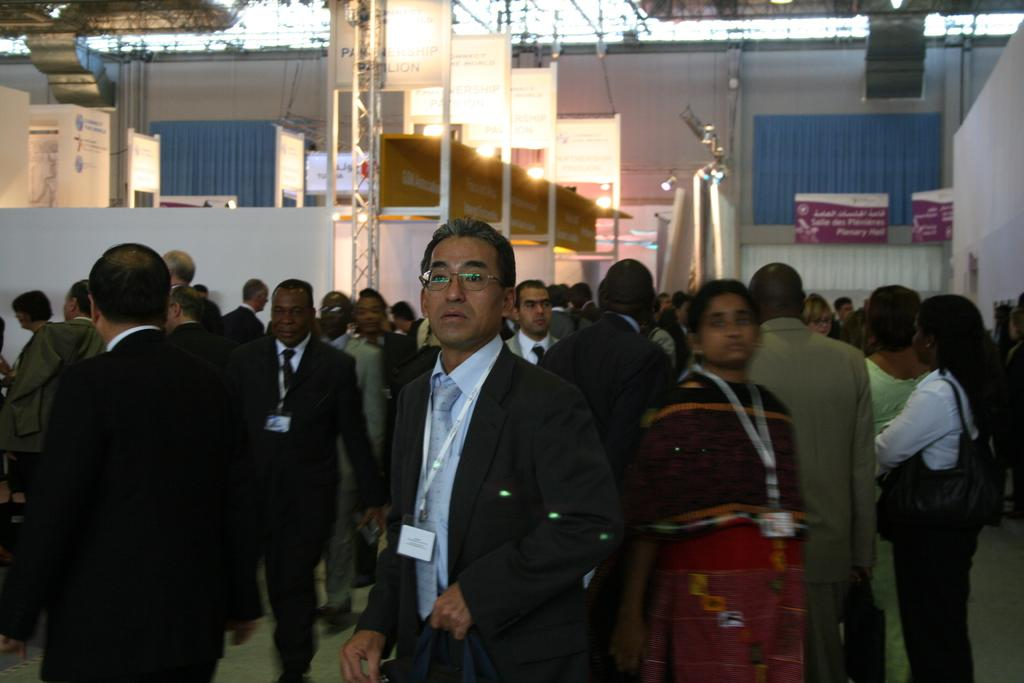What type of clothing are the people in the image wearing? The people in the image are wearing suits. Where are the people standing in the image? The people are standing on the floor. What can be seen above the people in the image? There are lights over the ceiling with metal frames in the image. What kind of location does the image appear to depict? The setting appears to be in a conference hall. What type of plantation can be seen in the background of the image? There is no plantation present in the image; it depicts a conference hall setting. 